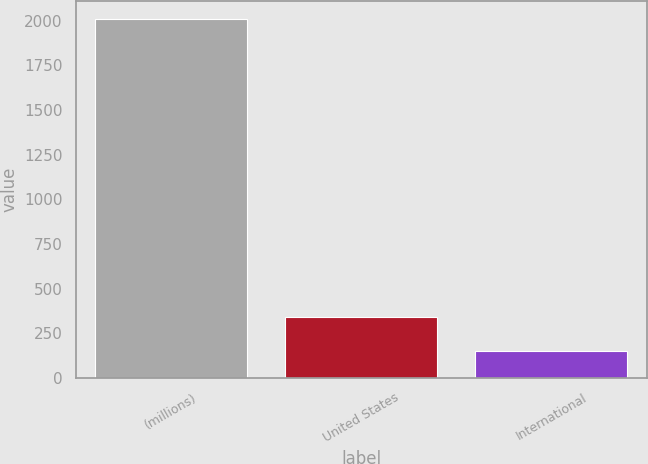Convert chart. <chart><loc_0><loc_0><loc_500><loc_500><bar_chart><fcel>(millions)<fcel>United States<fcel>International<nl><fcel>2011<fcel>338.7<fcel>152.7<nl></chart> 